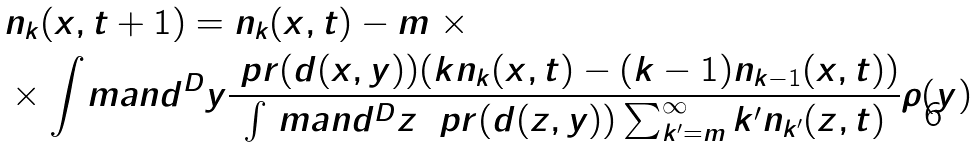Convert formula to latex. <formula><loc_0><loc_0><loc_500><loc_500>& n _ { k } ( x , t + 1 ) = n _ { k } ( x , t ) - m \ \times \\ & \times \int _ { \ } m a n d ^ { D } y \frac { \ p r ( d ( x , y ) ) ( k n _ { k } ( x , t ) - ( k - 1 ) n _ { k - 1 } ( x , t ) ) } { \int _ { \ } m a n d ^ { D } z \ \ p r ( d ( z , y ) ) \sum _ { k ^ { \prime } = m } ^ { \infty } { k ^ { \prime } } n _ { k ^ { \prime } } ( z , t ) } \rho ( y )</formula> 